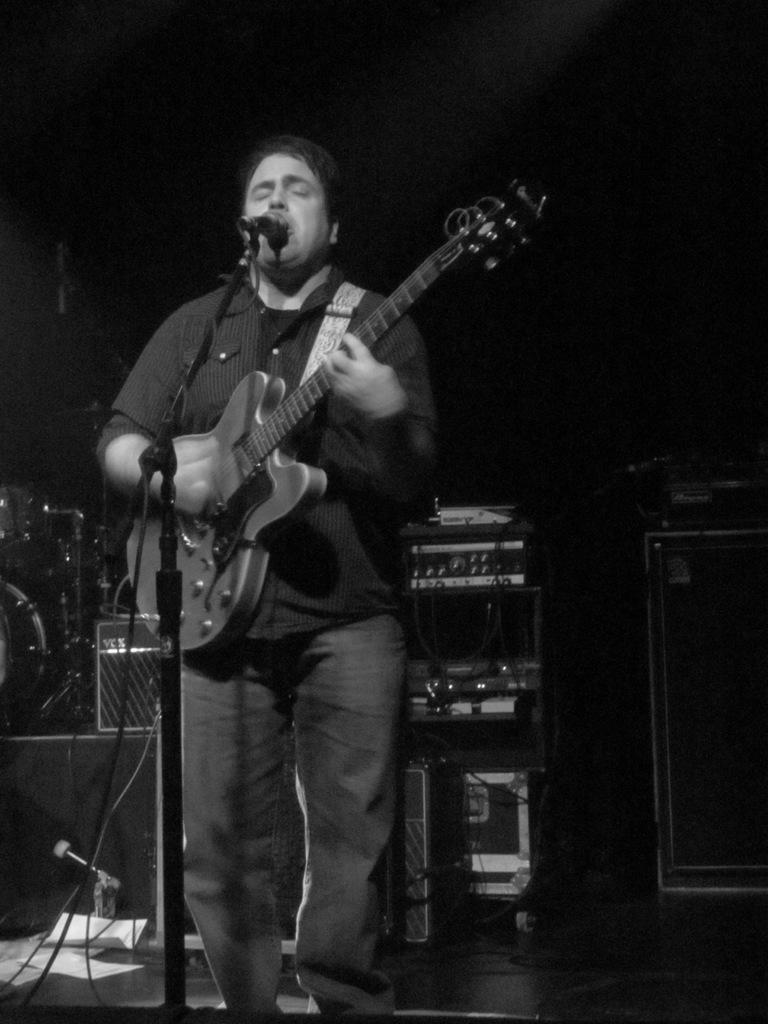Please provide a concise description of this image. As we can see in the image there is a man holding guitar and singing on mic. On floor there are papers and behind the man there are few musical instruments. 